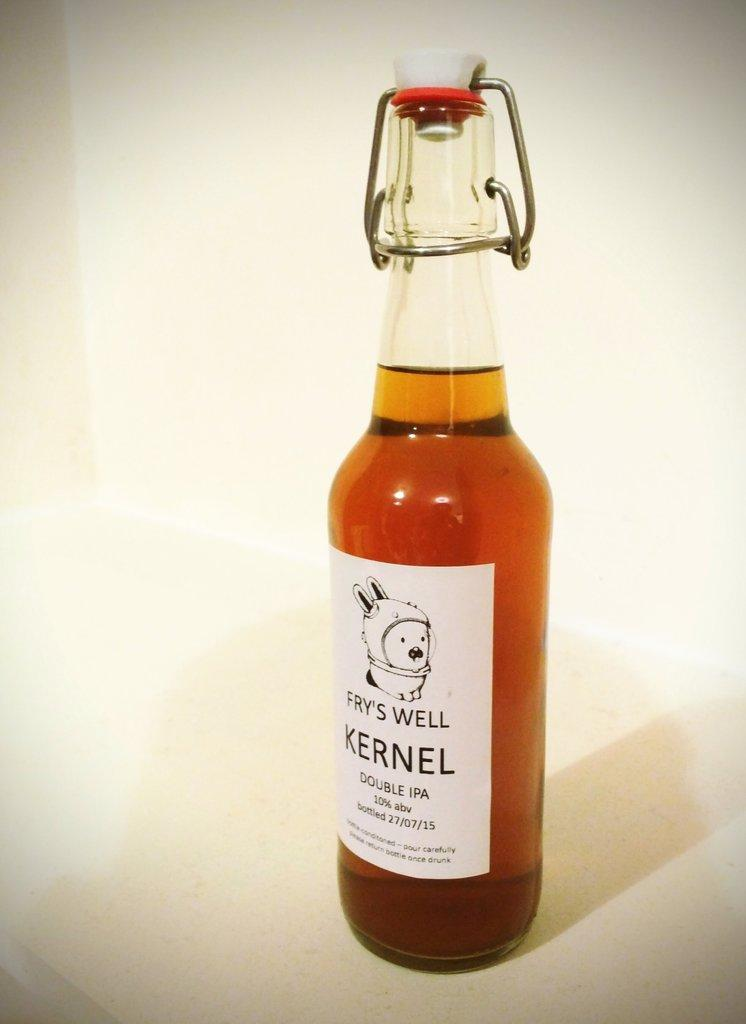<image>
Share a concise interpretation of the image provided. the word kernel is on the bottle of liquid 